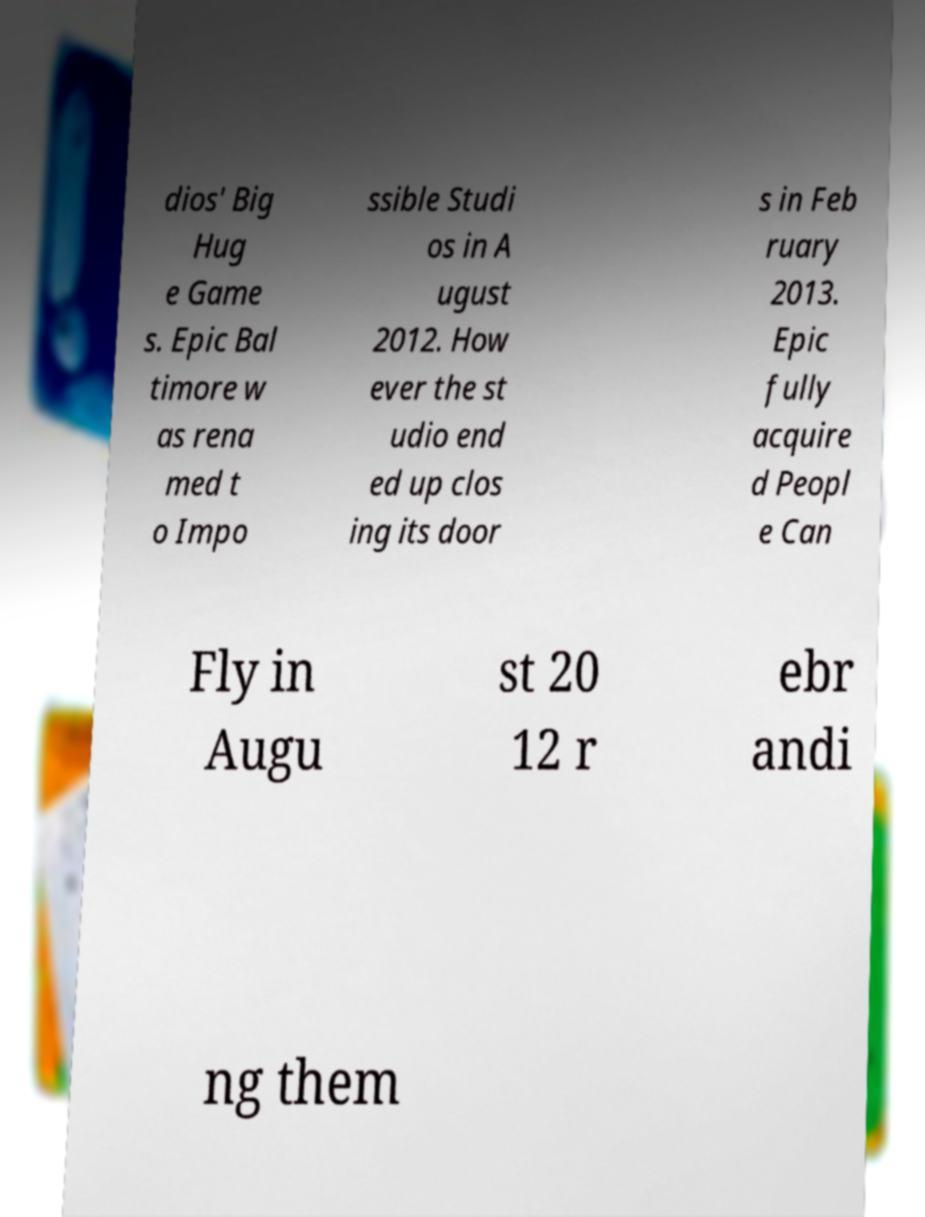Please identify and transcribe the text found in this image. dios' Big Hug e Game s. Epic Bal timore w as rena med t o Impo ssible Studi os in A ugust 2012. How ever the st udio end ed up clos ing its door s in Feb ruary 2013. Epic fully acquire d Peopl e Can Fly in Augu st 20 12 r ebr andi ng them 